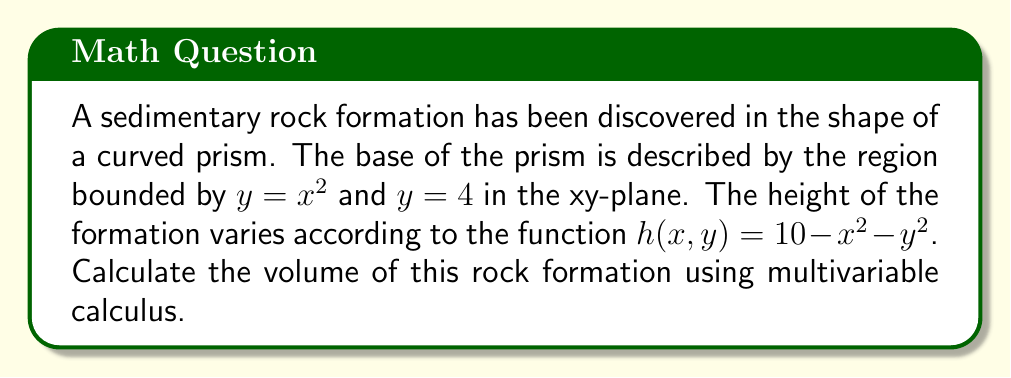Can you solve this math problem? Let's approach this step-by-step:

1) First, we need to set up a triple integral to calculate the volume. The volume is given by:

   $$ V = \iiint_R dV = \int\int_D \int_0^{h(x,y)} dz \, dA $$

   where $D$ is the base region and $h(x,y)$ is the height function.

2) Our base region $D$ is bounded by $y = x^2$ and $y = 4$. We can describe this region as:

   $$ D = \{(x,y) : x^2 \leq y \leq 4, -2 \leq x \leq 2\} $$

3) Now we can set up our triple integral:

   $$ V = \int_{-2}^2 \int_{x^2}^4 \int_0^{10-x^2-y^2} dz \, dy \, dx $$

4) Let's solve the innermost integral first:

   $$ V = \int_{-2}^2 \int_{x^2}^4 [z]_0^{10-x^2-y^2} \, dy \, dx $$
   $$ = \int_{-2}^2 \int_{x^2}^4 (10-x^2-y^2) \, dy \, dx $$

5) Now let's solve the middle integral:

   $$ V = \int_{-2}^2 \left[10y - x^2y - \frac{1}{3}y^3\right]_{x^2}^4 \, dx $$
   $$ = \int_{-2}^2 \left(40 - 4x^2 - \frac{64}{3} - (10x^2 - x^4 - \frac{x^6}{3})\right) \, dx $$
   $$ = \int_{-2}^2 \left(40 - \frac{64}{3} - 14x^2 + x^4 + \frac{x^6}{3}\right) \, dx $$

6) Finally, let's solve the outermost integral:

   $$ V = \left[40x - \frac{64}{3}x - \frac{14}{3}x^3 + \frac{1}{5}x^5 + \frac{1}{21}x^7\right]_{-2}^2 $$

7) Evaluating this at the limits:

   $$ V = \left(80 - \frac{128}{3} - \frac{112}{3} + \frac{32}{5} + \frac{128}{21}\right) - \left(-80 + \frac{128}{3} + \frac{112}{3} - \frac{32}{5} - \frac{128}{21}\right) $$

8) Simplifying:

   $$ V = 160 - \frac{256}{3} - \frac{224}{3} + \frac{64}{5} + \frac{256}{21} $$
   $$ = \frac{3360}{21} - \frac{1792}{21} - \frac{1568}{21} + \frac{268.8}{21} + \frac{256}{21} $$
   $$ = \frac{1524.8}{21} \approx 72.61 $$
Answer: $\frac{1524.8}{21}$ cubic units 